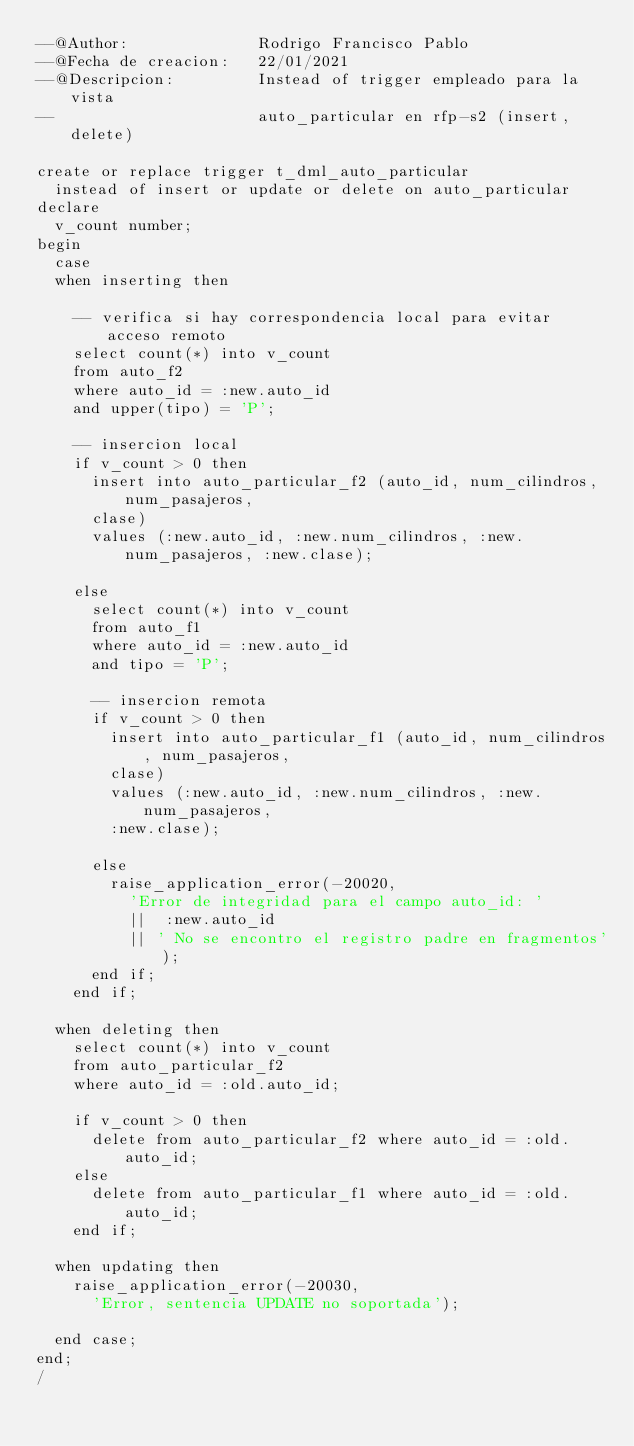<code> <loc_0><loc_0><loc_500><loc_500><_SQL_>--@Author:              Rodrigo Francisco Pablo
--@Fecha de creacion:   22/01/2021
--@Descripcion:         Instead of trigger empleado para la vista
--                      auto_particular en rfp-s2 (insert, delete)

create or replace trigger t_dml_auto_particular
  instead of insert or update or delete on auto_particular
declare
  v_count number;
begin 
  case
  when inserting then

    -- verifica si hay correspondencia local para evitar acceso remoto
    select count(*) into v_count
    from auto_f2
    where auto_id = :new.auto_id
    and upper(tipo) = 'P';

    -- insercion local
    if v_count > 0 then
      insert into auto_particular_f2 (auto_id, num_cilindros, num_pasajeros,
      clase)
      values (:new.auto_id, :new.num_cilindros, :new.num_pasajeros, :new.clase);

    else 
      select count(*) into v_count
      from auto_f1
      where auto_id = :new.auto_id
      and tipo = 'P';

      -- insercion remota
      if v_count > 0 then
        insert into auto_particular_f1 (auto_id, num_cilindros, num_pasajeros,
        clase)
        values (:new.auto_id, :new.num_cilindros, :new.num_pasajeros, 
        :new.clase);
      
      else
        raise_application_error(-20020, 
          'Error de integridad para el campo auto_id: '
          ||  :new.auto_id
          || ' No se encontro el registro padre en fragmentos');
      end if;
    end if;
  
  when deleting then
    select count(*) into v_count
    from auto_particular_f2
    where auto_id = :old.auto_id;

    if v_count > 0 then
      delete from auto_particular_f2 where auto_id = :old.auto_id;
    else
      delete from auto_particular_f1 where auto_id = :old.auto_id;
    end if;

  when updating then
    raise_application_error(-20030, 
      'Error, sentencia UPDATE no soportada');
  
  end case;
end;
/


</code> 